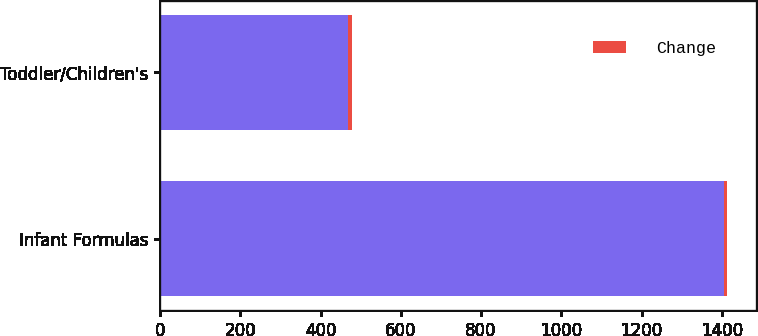Convert chart to OTSL. <chart><loc_0><loc_0><loc_500><loc_500><stacked_bar_chart><ecel><fcel>Infant Formulas<fcel>Toddler/Children's<nl><fcel>nan<fcel>1405<fcel>468<nl><fcel>Change<fcel>9<fcel>11<nl></chart> 